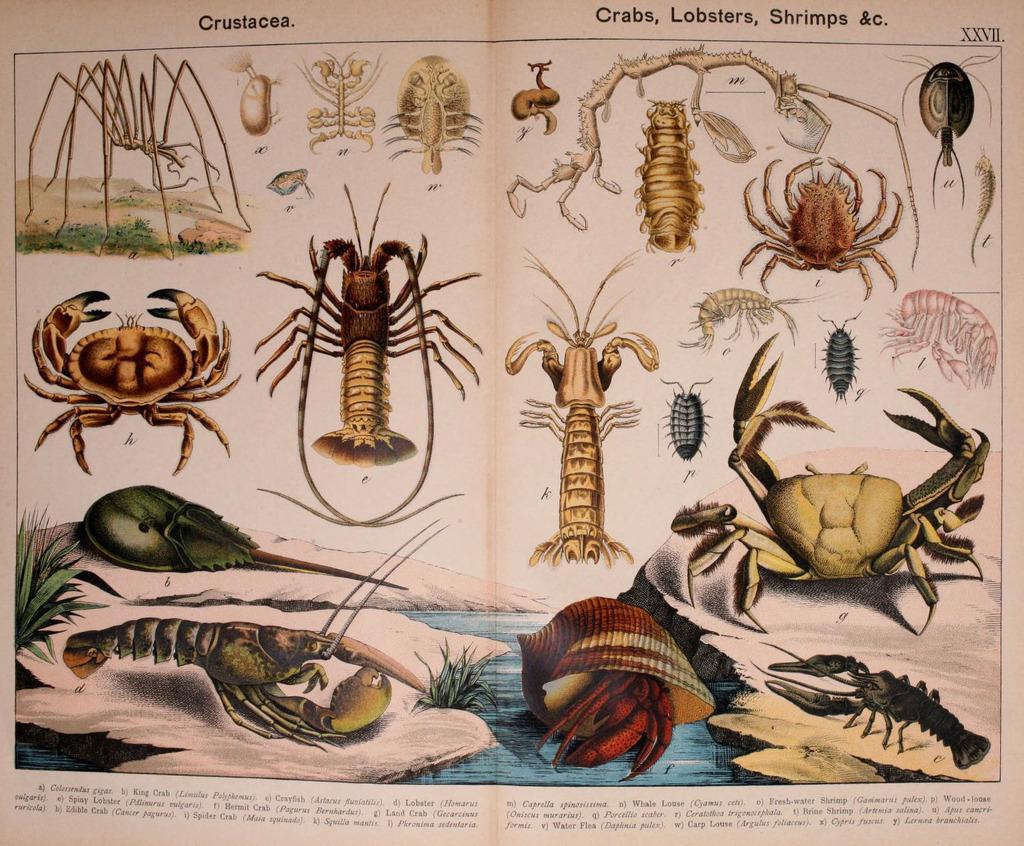Describe this image in one or two sentences. This image consists of a paper with a few images of crabs, prawns, spiders, shells, a few insects and there is a text on it. 